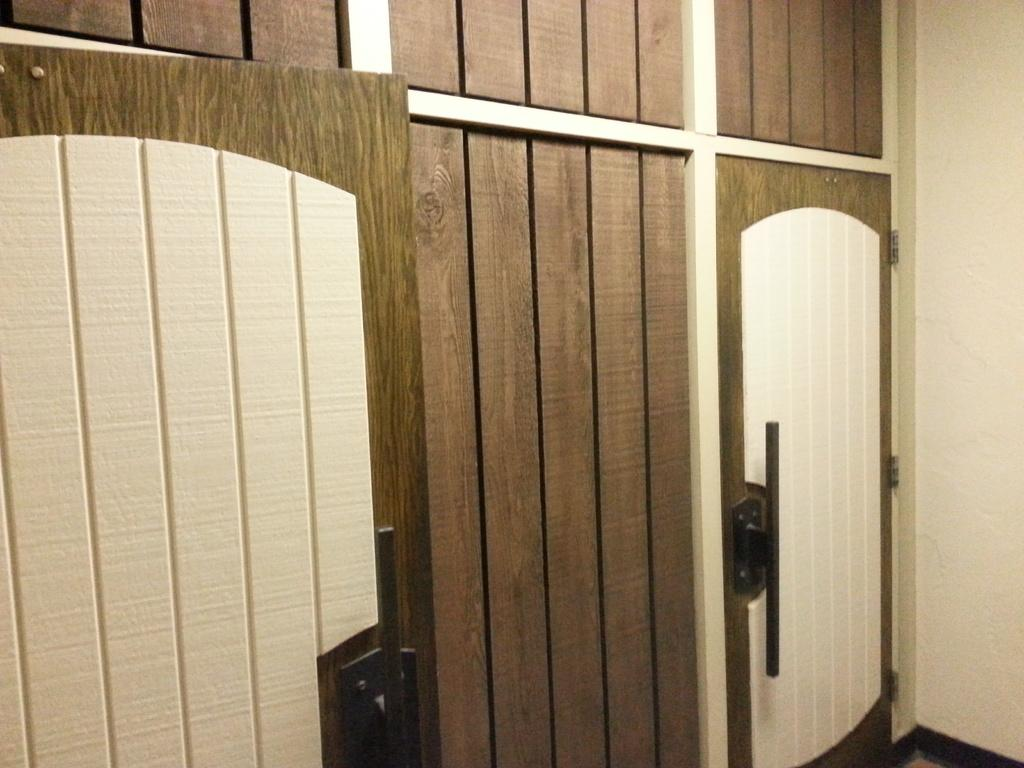What type of doors are visible in the image? There are wooden doors in the image. What color is the wall behind the doors? There is a cream-colored wall in the image. What type of meat is being prepared in the wilderness in the image? There is no meat or wilderness present in the image; it only features wooden doors and a cream-colored wall. 